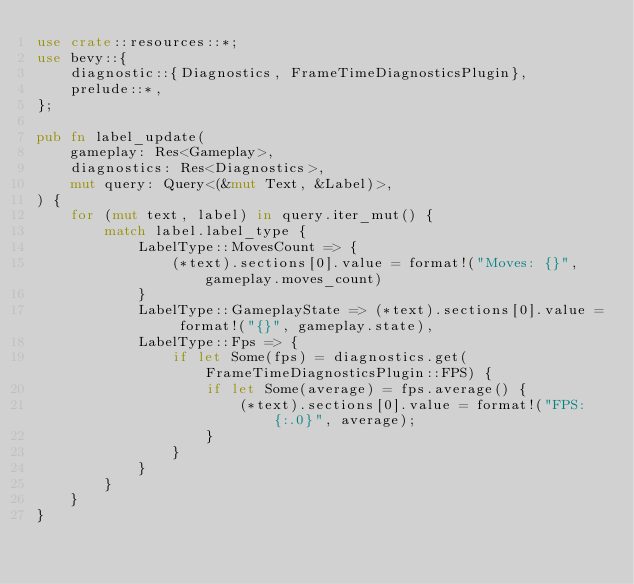<code> <loc_0><loc_0><loc_500><loc_500><_Rust_>use crate::resources::*;
use bevy::{
    diagnostic::{Diagnostics, FrameTimeDiagnosticsPlugin},
    prelude::*,
};

pub fn label_update(
    gameplay: Res<Gameplay>,
    diagnostics: Res<Diagnostics>,
    mut query: Query<(&mut Text, &Label)>,
) {
    for (mut text, label) in query.iter_mut() {
        match label.label_type {
            LabelType::MovesCount => {
                (*text).sections[0].value = format!("Moves: {}", gameplay.moves_count)
            }
            LabelType::GameplayState => (*text).sections[0].value = format!("{}", gameplay.state),
            LabelType::Fps => {
                if let Some(fps) = diagnostics.get(FrameTimeDiagnosticsPlugin::FPS) {
                    if let Some(average) = fps.average() {
                        (*text).sections[0].value = format!("FPS: {:.0}", average);
                    }
                }
            }
        }
    }
}
</code> 